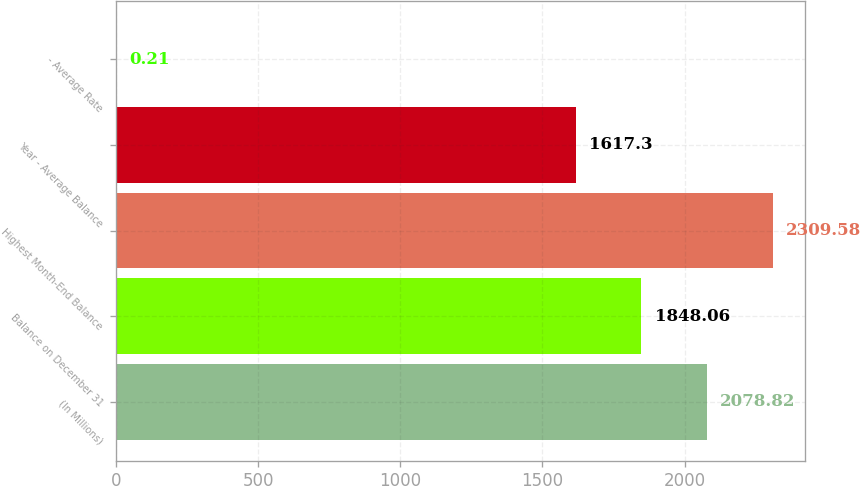<chart> <loc_0><loc_0><loc_500><loc_500><bar_chart><fcel>(In Millions)<fcel>Balance on December 31<fcel>Highest Month-End Balance<fcel>Year - Average Balance<fcel>- Average Rate<nl><fcel>2078.82<fcel>1848.06<fcel>2309.58<fcel>1617.3<fcel>0.21<nl></chart> 